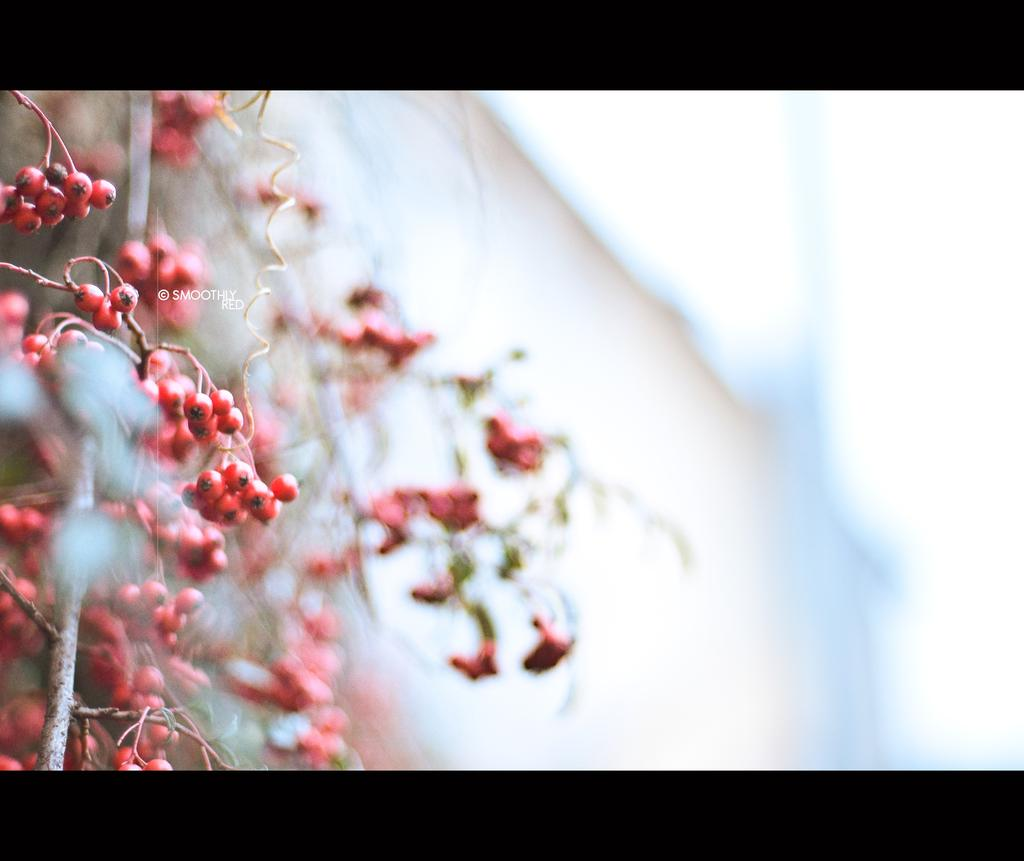What is present in the image? There is a plant in the image. What can be observed about the plant? The plant has fruits on it. What type of shirt is the aunt wearing in the image? There is no aunt or shirt present in the image; it only features a plant with fruits. 